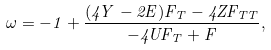<formula> <loc_0><loc_0><loc_500><loc_500>\omega = - 1 + \frac { ( 4 Y - 2 E ) F _ { T } - 4 Z F _ { T T } } { - 4 U F _ { T } + F } ,</formula> 